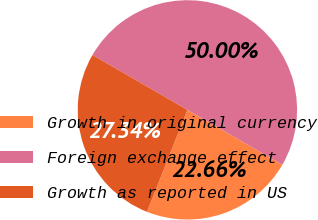<chart> <loc_0><loc_0><loc_500><loc_500><pie_chart><fcel>Growth in original currency<fcel>Foreign exchange effect<fcel>Growth as reported in US<nl><fcel>22.66%<fcel>50.0%<fcel>27.34%<nl></chart> 